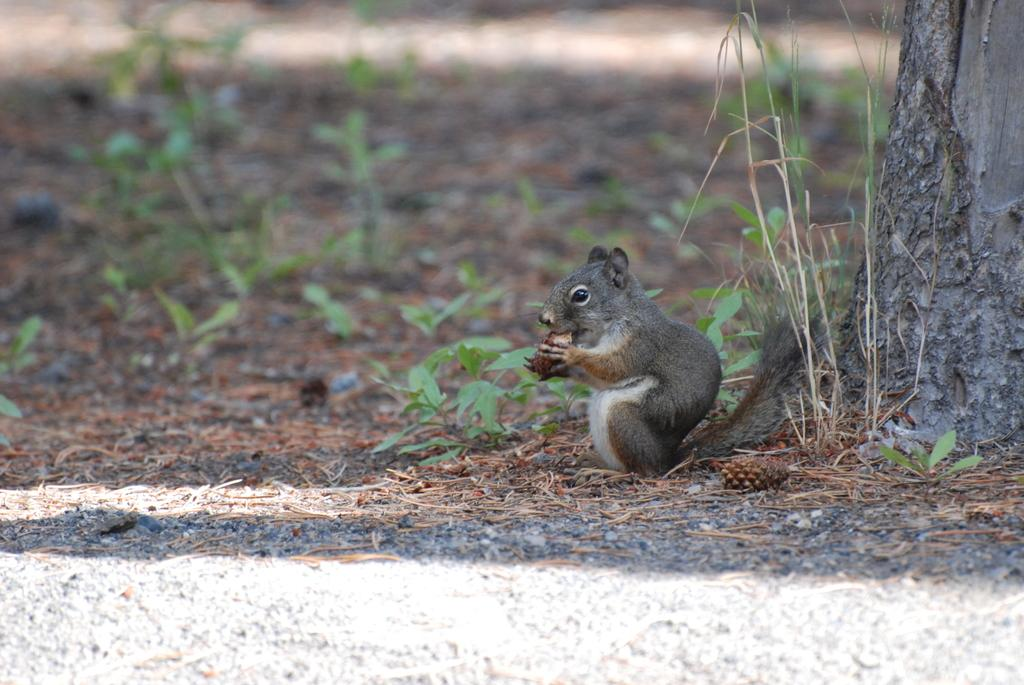What type of animal is in the image? There is a fox squirrel in the image. What is the fox squirrel doing in the image? The fox squirrel is holding an object. Where is the object located in relation to the tree trunk? The object is visible in front of a tree trunk. What celestial bodies can be seen in the image? There are planets visible in the image. What type of quilt is being used to cover the fox squirrel's hate for the tree trunk in the image? There is no quilt or expression of hate present in the image; it features a fox squirrel holding an object in front of a tree trunk. 